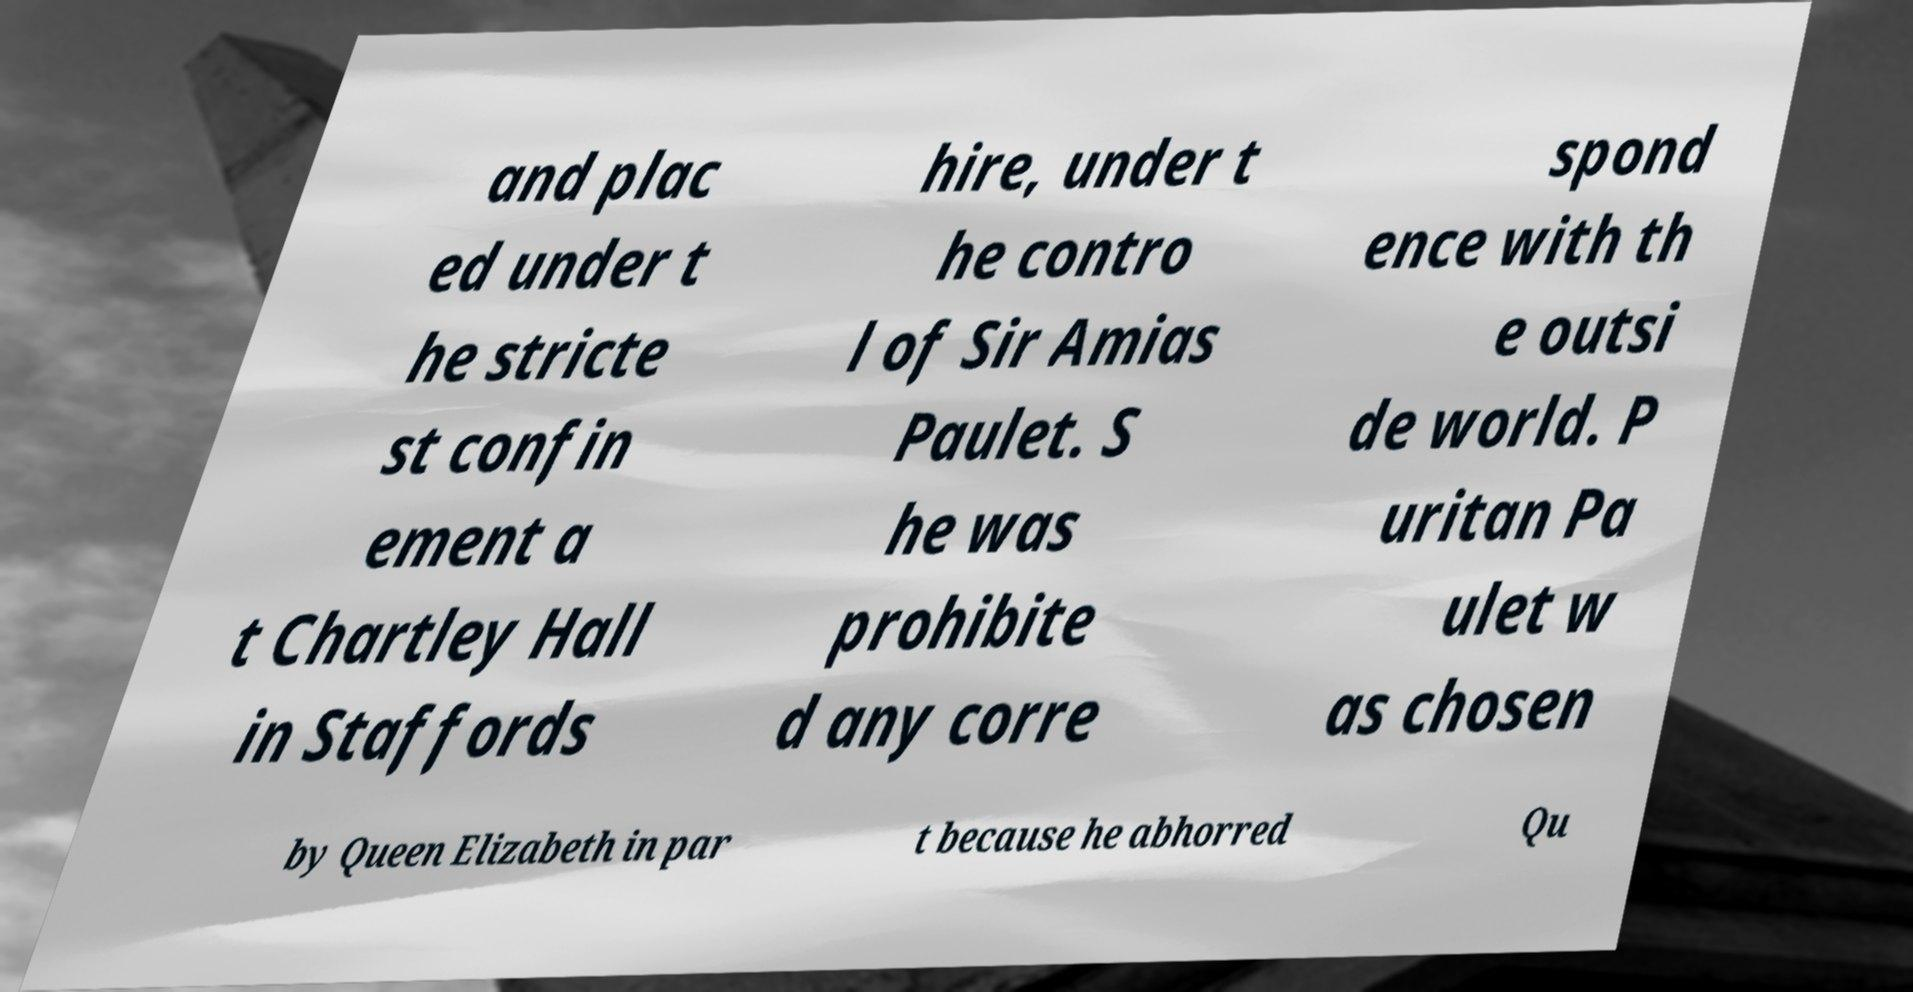What messages or text are displayed in this image? I need them in a readable, typed format. and plac ed under t he stricte st confin ement a t Chartley Hall in Staffords hire, under t he contro l of Sir Amias Paulet. S he was prohibite d any corre spond ence with th e outsi de world. P uritan Pa ulet w as chosen by Queen Elizabeth in par t because he abhorred Qu 